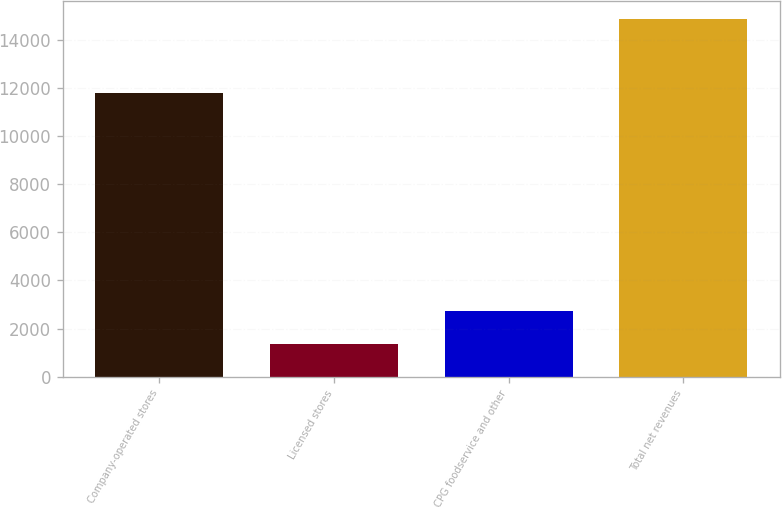Convert chart. <chart><loc_0><loc_0><loc_500><loc_500><bar_chart><fcel>Company-operated stores<fcel>Licensed stores<fcel>CPG foodservice and other<fcel>Total net revenues<nl><fcel>11793.2<fcel>1360.5<fcel>2711.13<fcel>14866.8<nl></chart> 